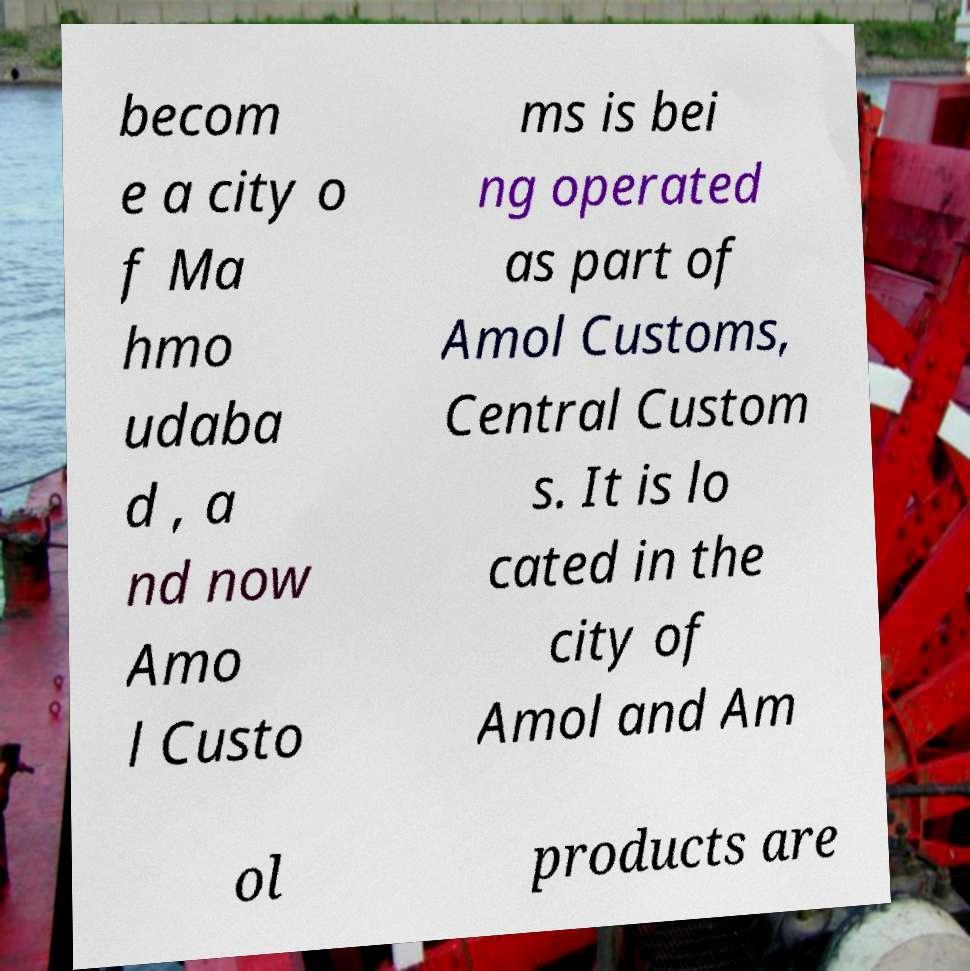There's text embedded in this image that I need extracted. Can you transcribe it verbatim? becom e a city o f Ma hmo udaba d , a nd now Amo l Custo ms is bei ng operated as part of Amol Customs, Central Custom s. It is lo cated in the city of Amol and Am ol products are 